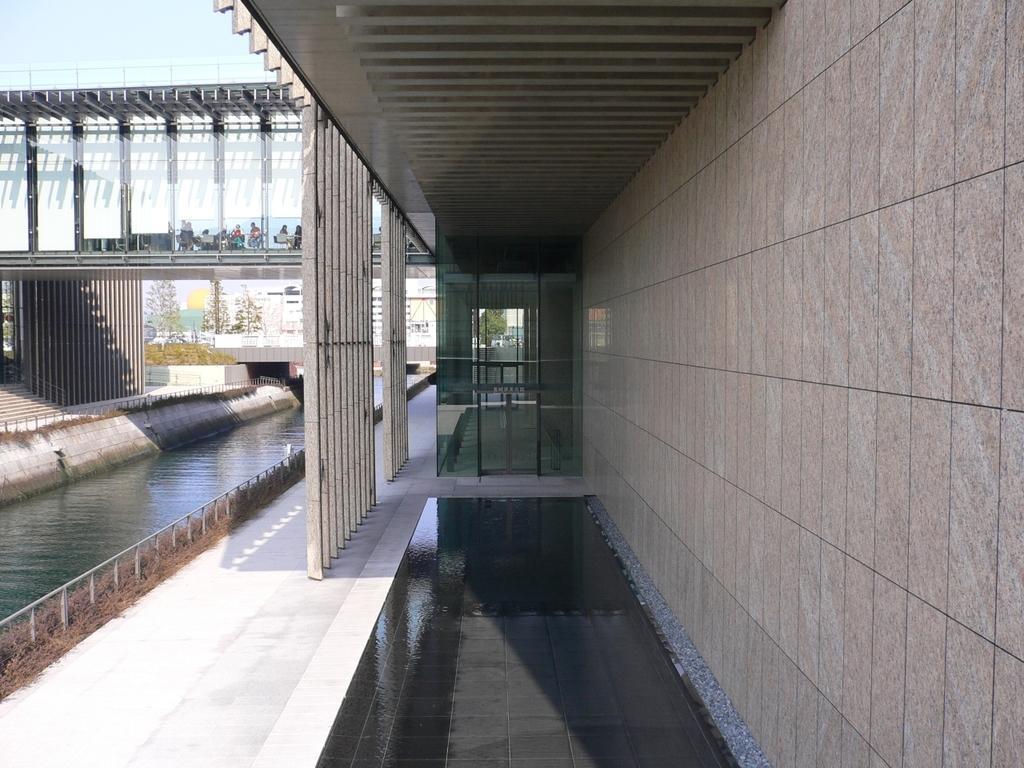Could you give a brief overview of what you see in this image? There are water in the left corner and there is a bridge above it and there are few people sitting in the left corner and there are buildings in the background. 